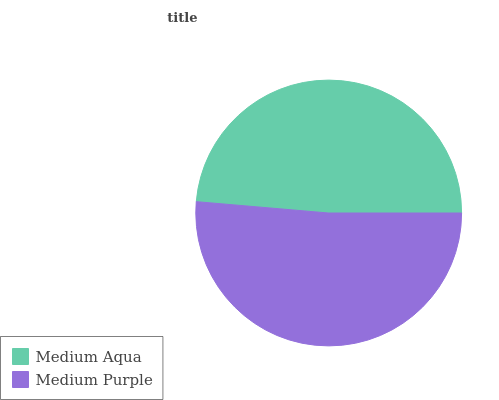Is Medium Aqua the minimum?
Answer yes or no. Yes. Is Medium Purple the maximum?
Answer yes or no. Yes. Is Medium Purple the minimum?
Answer yes or no. No. Is Medium Purple greater than Medium Aqua?
Answer yes or no. Yes. Is Medium Aqua less than Medium Purple?
Answer yes or no. Yes. Is Medium Aqua greater than Medium Purple?
Answer yes or no. No. Is Medium Purple less than Medium Aqua?
Answer yes or no. No. Is Medium Purple the high median?
Answer yes or no. Yes. Is Medium Aqua the low median?
Answer yes or no. Yes. Is Medium Aqua the high median?
Answer yes or no. No. Is Medium Purple the low median?
Answer yes or no. No. 